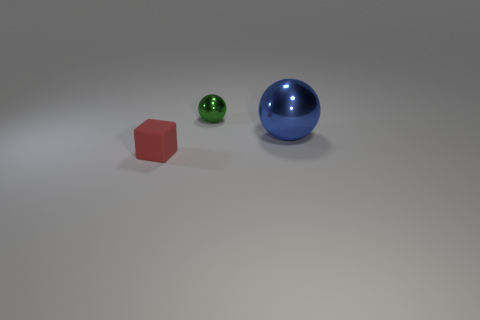Is there anything else that has the same size as the blue metallic thing?
Offer a terse response. No. Is there anything else that has the same shape as the red rubber object?
Provide a short and direct response. No. The other object that is the same size as the rubber thing is what color?
Ensure brevity in your answer.  Green. Is there a green metal object?
Make the answer very short. Yes. The small thing that is to the right of the matte cube has what shape?
Provide a succinct answer. Sphere. What number of objects are in front of the small green metallic thing and on the right side of the red matte block?
Make the answer very short. 1. Is there a big blue thing made of the same material as the tiny sphere?
Give a very brief answer. Yes. How many cubes are either small green objects or blue metal things?
Provide a succinct answer. 0. The block is what size?
Offer a very short reply. Small. How many small green shiny objects are right of the tiny ball?
Ensure brevity in your answer.  0. 